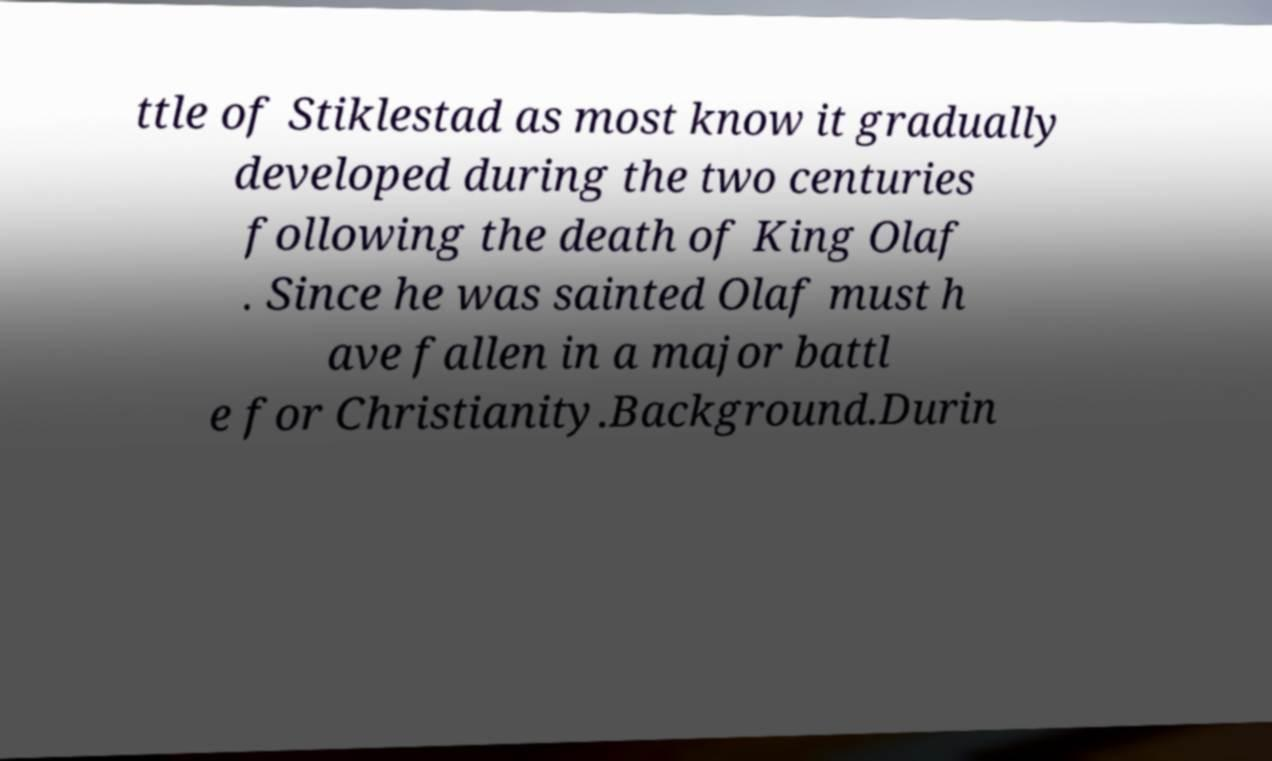Can you accurately transcribe the text from the provided image for me? ttle of Stiklestad as most know it gradually developed during the two centuries following the death of King Olaf . Since he was sainted Olaf must h ave fallen in a major battl e for Christianity.Background.Durin 